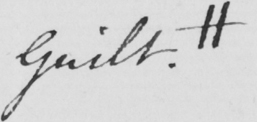What text is written in this handwritten line? Guilt . # 